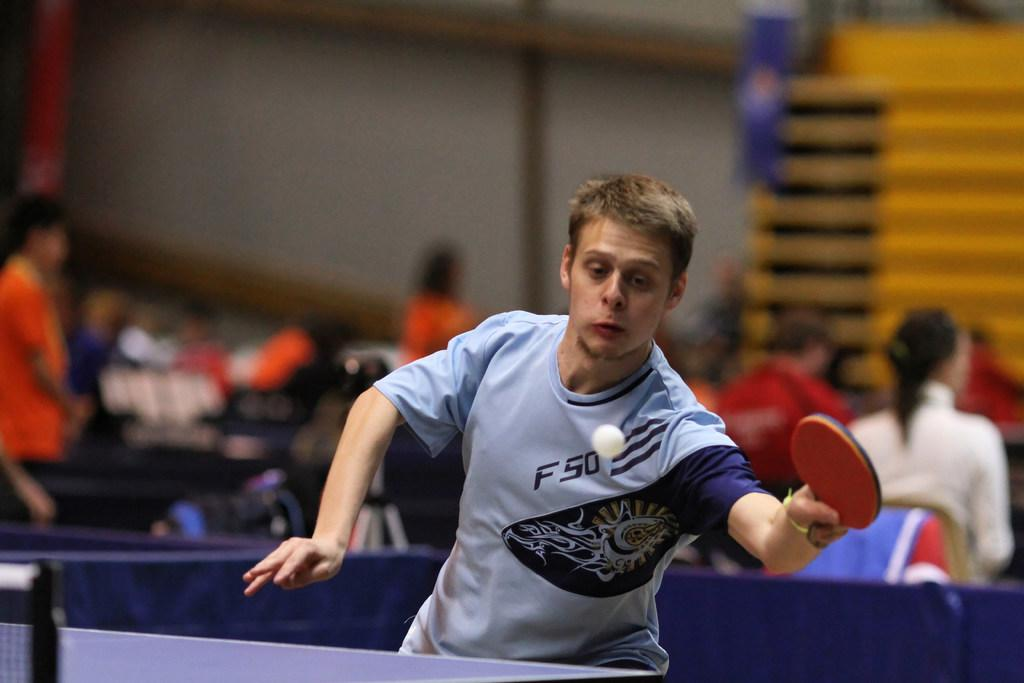<image>
Create a compact narrative representing the image presented. a person used a paddle to hit a ball with f 50 on their shirt 